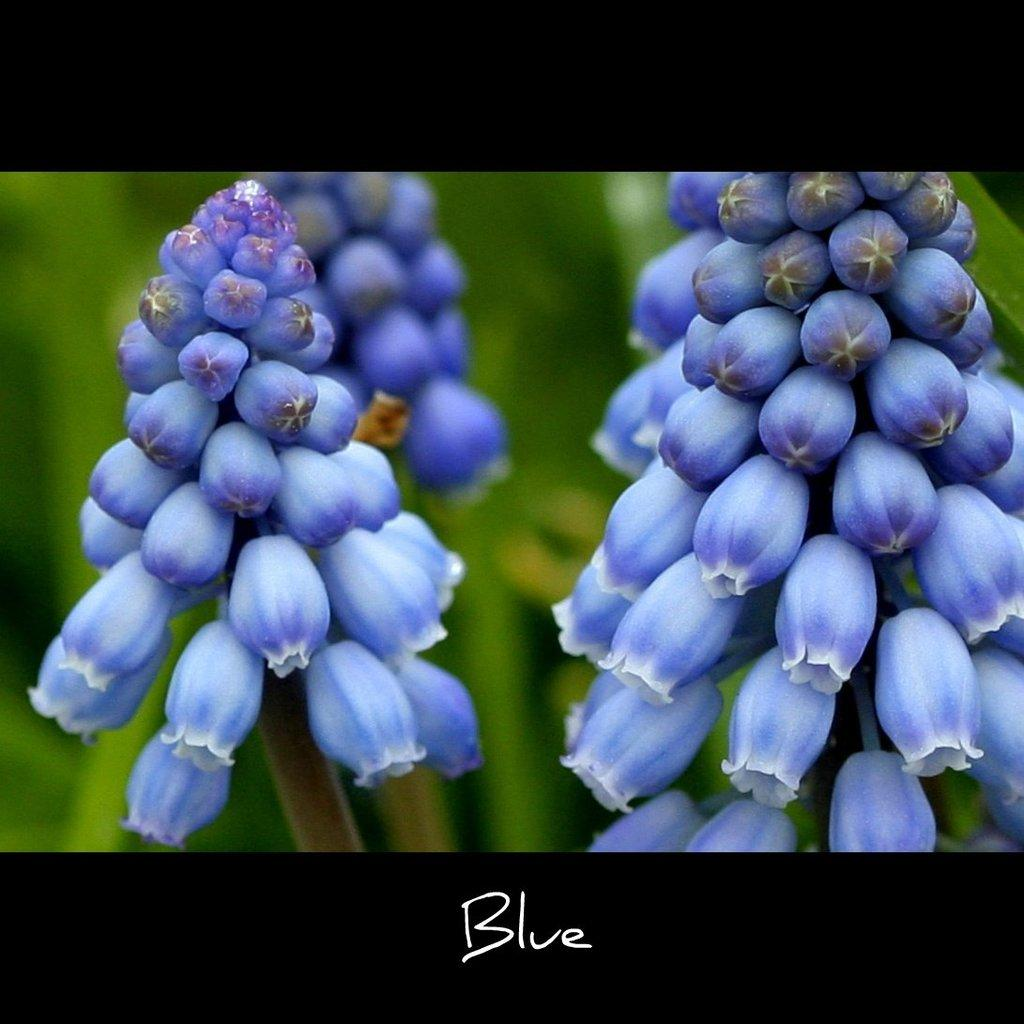What type of flora is present in the image? There are flowers in the image. What color are the flowers? The flowers are blue. What else can be seen in the background of the image? There is a plant in the background of the image. What is located at the bottom of the image? There is text at the bottom of the image. How does the grass in the image affect the mass of the flowers? There is no grass present in the image, so it cannot affect the mass of the flowers. 